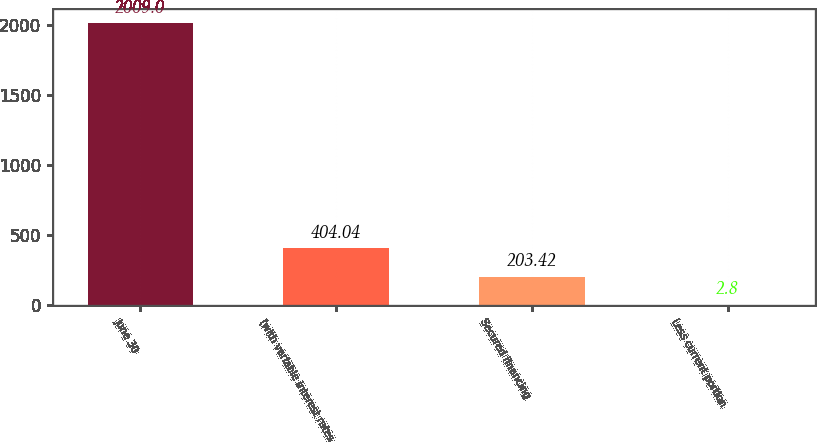<chart> <loc_0><loc_0><loc_500><loc_500><bar_chart><fcel>June 30<fcel>(with variable interest rates<fcel>Secured financing<fcel>Less current portion<nl><fcel>2009<fcel>404.04<fcel>203.42<fcel>2.8<nl></chart> 